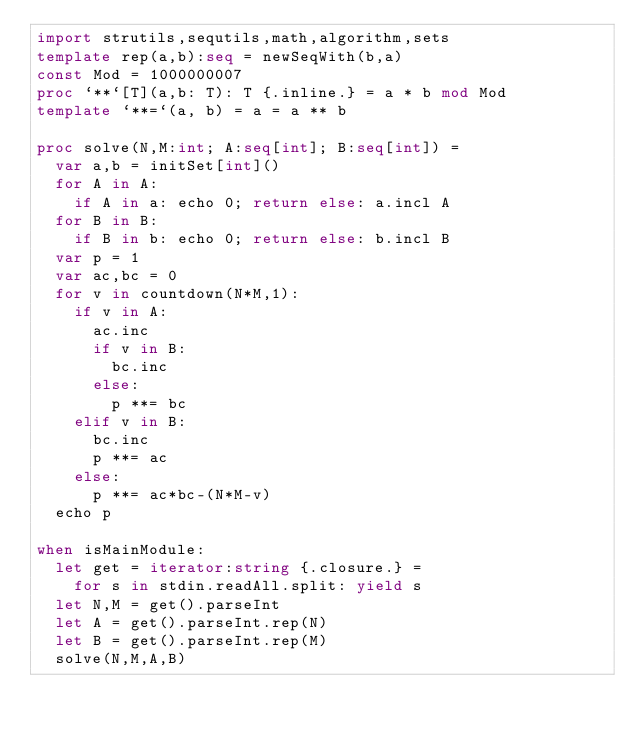Convert code to text. <code><loc_0><loc_0><loc_500><loc_500><_Nim_>import strutils,sequtils,math,algorithm,sets
template rep(a,b):seq = newSeqWith(b,a)
const Mod = 1000000007
proc `**`[T](a,b: T): T {.inline.} = a * b mod Mod
template `**=`(a, b) = a = a ** b

proc solve(N,M:int; A:seq[int]; B:seq[int]) =
  var a,b = initSet[int]()
  for A in A:
    if A in a: echo 0; return else: a.incl A
  for B in B:
    if B in b: echo 0; return else: b.incl B
  var p = 1
  var ac,bc = 0
  for v in countdown(N*M,1):
    if v in A:
      ac.inc
      if v in B:
        bc.inc
      else:
        p **= bc
    elif v in B:
      bc.inc
      p **= ac
    else:
      p **= ac*bc-(N*M-v)
  echo p

when isMainModule:
  let get = iterator:string {.closure.} = 
    for s in stdin.readAll.split: yield s
  let N,M = get().parseInt
  let A = get().parseInt.rep(N)
  let B = get().parseInt.rep(M)
  solve(N,M,A,B)

</code> 